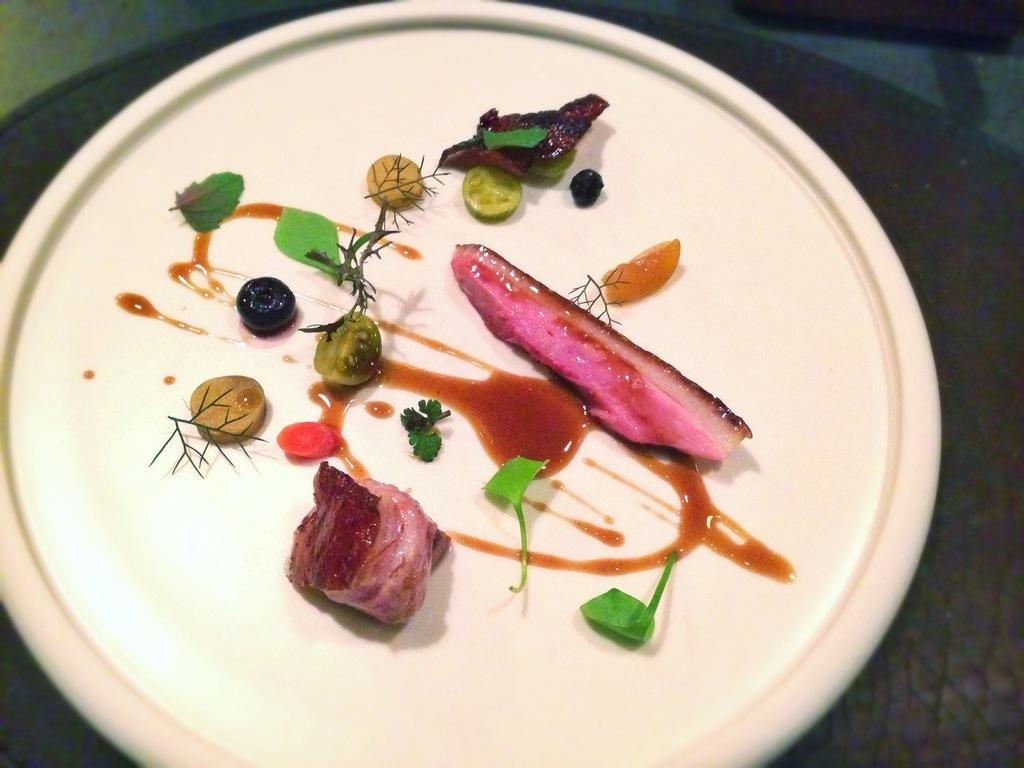In one or two sentences, can you explain what this image depicts? In this image, we can see some food items on a plate placed on the surface. 